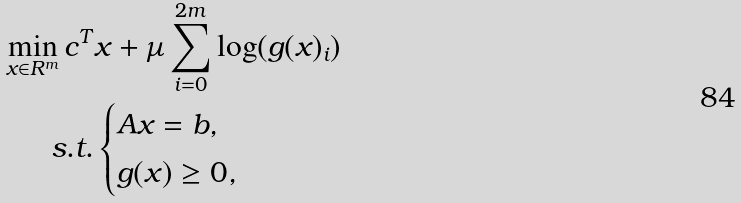Convert formula to latex. <formula><loc_0><loc_0><loc_500><loc_500>\min _ { x \in R ^ { m } } c ^ { T } & x + \mu \sum _ { i = 0 } ^ { 2 m } \log ( g ( x ) _ { i } ) \\ s . t . & \begin{cases} A x = b , \\ g ( x ) \geq 0 , \\ \end{cases}</formula> 